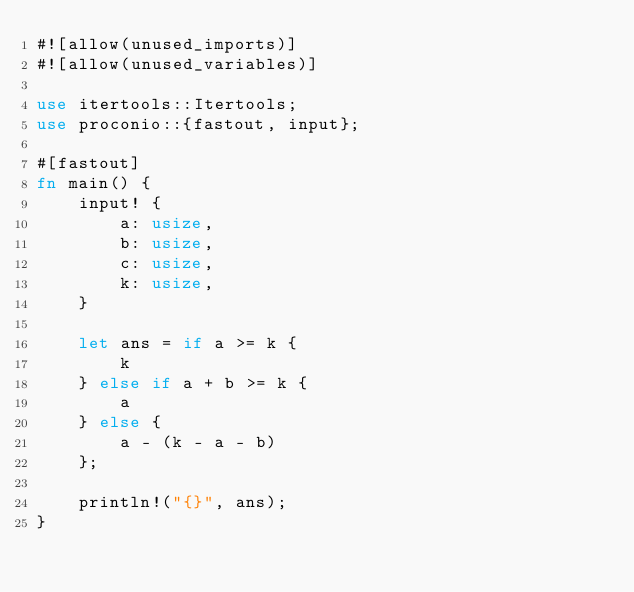Convert code to text. <code><loc_0><loc_0><loc_500><loc_500><_Rust_>#![allow(unused_imports)]
#![allow(unused_variables)]

use itertools::Itertools;
use proconio::{fastout, input};

#[fastout]
fn main() {
    input! {
        a: usize,
        b: usize,
        c: usize,
        k: usize,
    }

    let ans = if a >= k {
        k
    } else if a + b >= k {
        a
    } else {
        a - (k - a - b)
    };

    println!("{}", ans);
}
</code> 